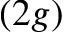Convert formula to latex. <formula><loc_0><loc_0><loc_500><loc_500>( 2 g )</formula> 